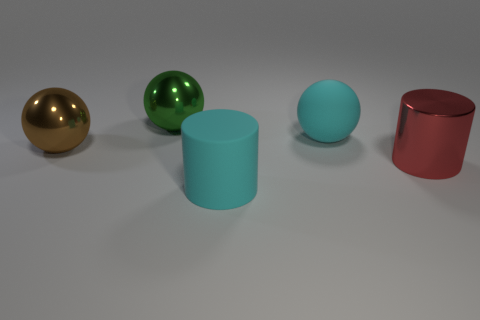There is a rubber object to the right of the matte cylinder; does it have the same color as the big matte cylinder?
Provide a short and direct response. Yes. What is the shape of the big brown thing that is the same material as the green ball?
Keep it short and to the point. Sphere. There is a thing that is both behind the large cyan matte cylinder and in front of the brown metallic thing; what is its color?
Provide a succinct answer. Red. What is the size of the cyan object to the right of the big cyan thing that is in front of the large cyan sphere?
Your answer should be compact. Large. Is there a big object that has the same color as the big rubber ball?
Ensure brevity in your answer.  Yes. Is the number of cyan balls to the right of the cyan rubber sphere the same as the number of tiny cyan blocks?
Provide a short and direct response. Yes. What number of large gray cubes are there?
Provide a succinct answer. 0. The object that is both right of the green metal ball and behind the large metal cylinder has what shape?
Provide a succinct answer. Sphere. There is a large matte object on the left side of the cyan rubber sphere; is it the same color as the large matte object that is behind the large brown sphere?
Give a very brief answer. Yes. Are there any large spheres that have the same material as the large green object?
Your response must be concise. Yes. 